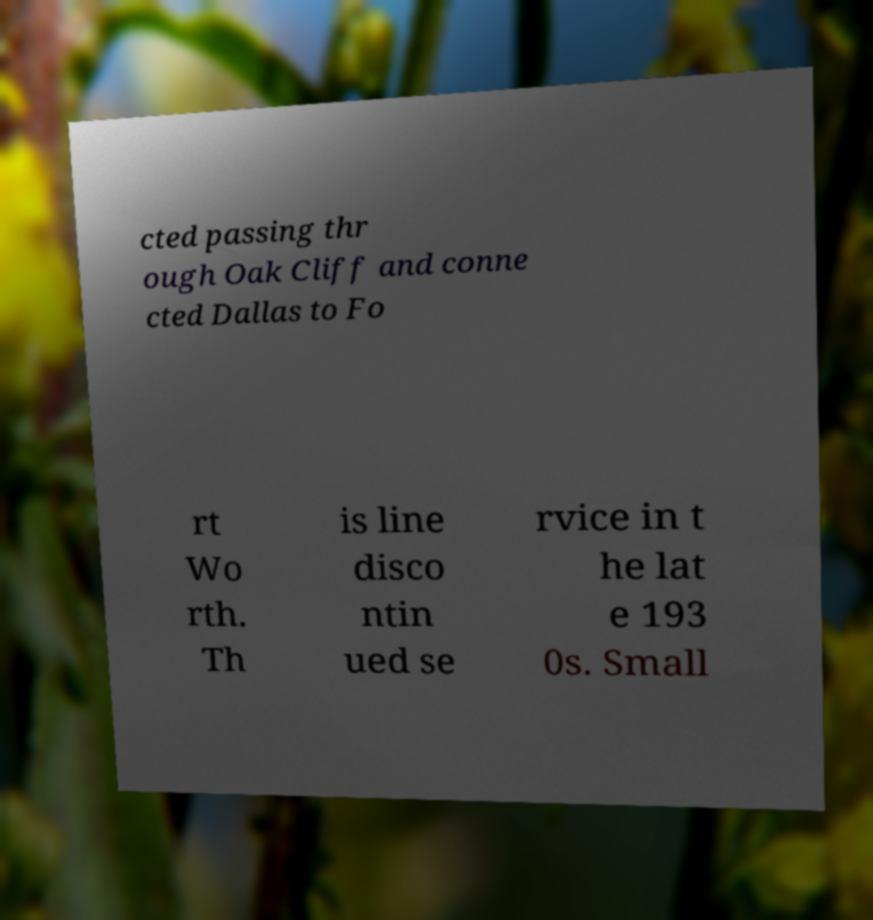Could you extract and type out the text from this image? cted passing thr ough Oak Cliff and conne cted Dallas to Fo rt Wo rth. Th is line disco ntin ued se rvice in t he lat e 193 0s. Small 